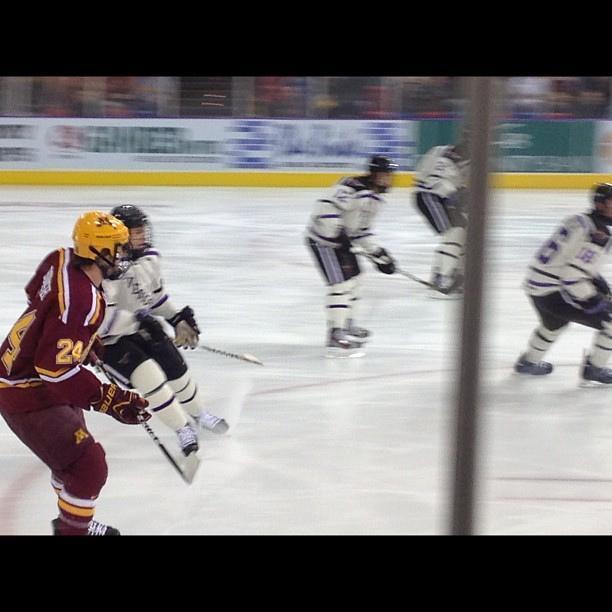What foot appeared are the hockey players wearing to play on the ice?
Select the accurate response from the four choices given to answer the question.
Options: Cleats, skates, rollerblades, sticks. Skates. 